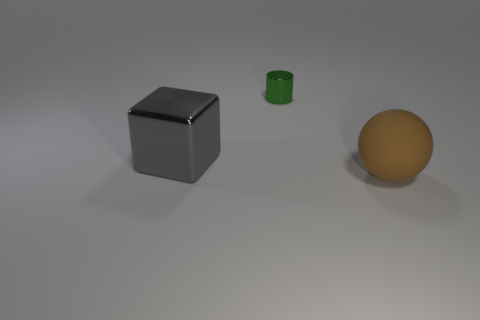There is a green thing that is made of the same material as the large gray thing; what shape is it?
Your answer should be very brief. Cylinder. The big object on the right side of the large object that is left of the object to the right of the shiny cylinder is made of what material?
Your answer should be compact. Rubber. There is a sphere; is its size the same as the shiny object behind the large gray shiny block?
Offer a terse response. No. There is a thing that is behind the big thing on the left side of the large object that is on the right side of the small green shiny cylinder; what size is it?
Offer a very short reply. Small. Do the brown sphere and the gray metal thing have the same size?
Ensure brevity in your answer.  Yes. There is a thing right of the shiny thing that is to the right of the big gray metallic thing; what is its material?
Offer a terse response. Rubber. There is a thing that is in front of the big gray thing; is it the same shape as the object to the left of the green cylinder?
Your response must be concise. No. Are there an equal number of matte spheres behind the green thing and red rubber cubes?
Your answer should be very brief. Yes. There is a big thing that is on the left side of the brown object; is there a large ball that is behind it?
Make the answer very short. No. Is there any other thing that has the same color as the ball?
Your response must be concise. No. 